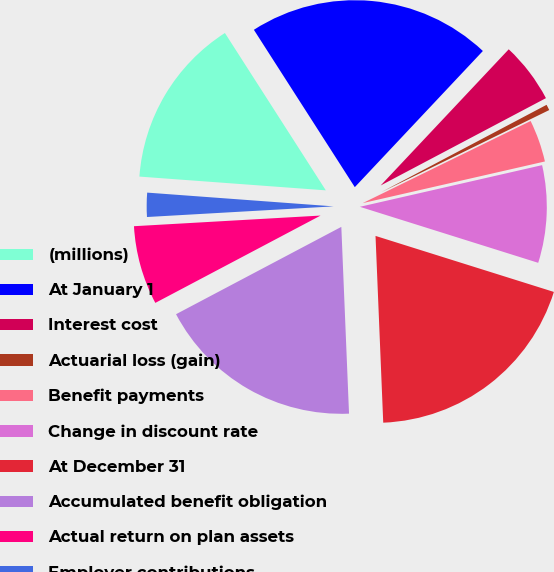<chart> <loc_0><loc_0><loc_500><loc_500><pie_chart><fcel>(millions)<fcel>At January 1<fcel>Interest cost<fcel>Actuarial loss (gain)<fcel>Benefit payments<fcel>Change in discount rate<fcel>At December 31<fcel>Accumulated benefit obligation<fcel>Actual return on plan assets<fcel>Employer contributions<nl><fcel>14.75%<fcel>21.09%<fcel>5.25%<fcel>0.5%<fcel>3.66%<fcel>8.42%<fcel>19.5%<fcel>17.92%<fcel>6.83%<fcel>2.08%<nl></chart> 